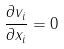Convert formula to latex. <formula><loc_0><loc_0><loc_500><loc_500>\frac { \partial v _ { i } } { \partial x _ { i } } = 0</formula> 